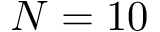<formula> <loc_0><loc_0><loc_500><loc_500>N = 1 0</formula> 